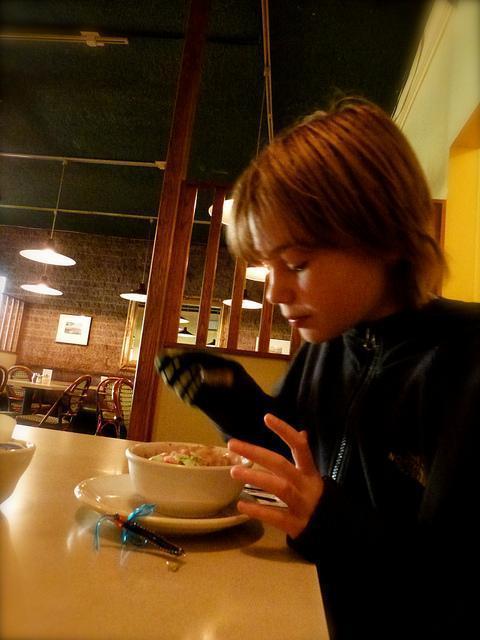How many hot dogs are there?
Give a very brief answer. 0. 